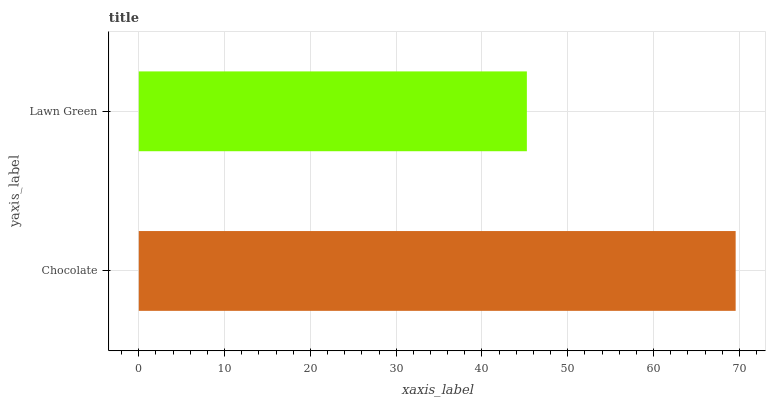Is Lawn Green the minimum?
Answer yes or no. Yes. Is Chocolate the maximum?
Answer yes or no. Yes. Is Lawn Green the maximum?
Answer yes or no. No. Is Chocolate greater than Lawn Green?
Answer yes or no. Yes. Is Lawn Green less than Chocolate?
Answer yes or no. Yes. Is Lawn Green greater than Chocolate?
Answer yes or no. No. Is Chocolate less than Lawn Green?
Answer yes or no. No. Is Chocolate the high median?
Answer yes or no. Yes. Is Lawn Green the low median?
Answer yes or no. Yes. Is Lawn Green the high median?
Answer yes or no. No. Is Chocolate the low median?
Answer yes or no. No. 